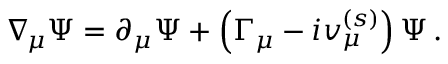Convert formula to latex. <formula><loc_0><loc_0><loc_500><loc_500>\nabla _ { \, \mu } \Psi = \partial _ { \mu } \Psi + \left ( \Gamma _ { \mu } - i v _ { \mu } ^ { ( s ) } \right ) \Psi \, .</formula> 